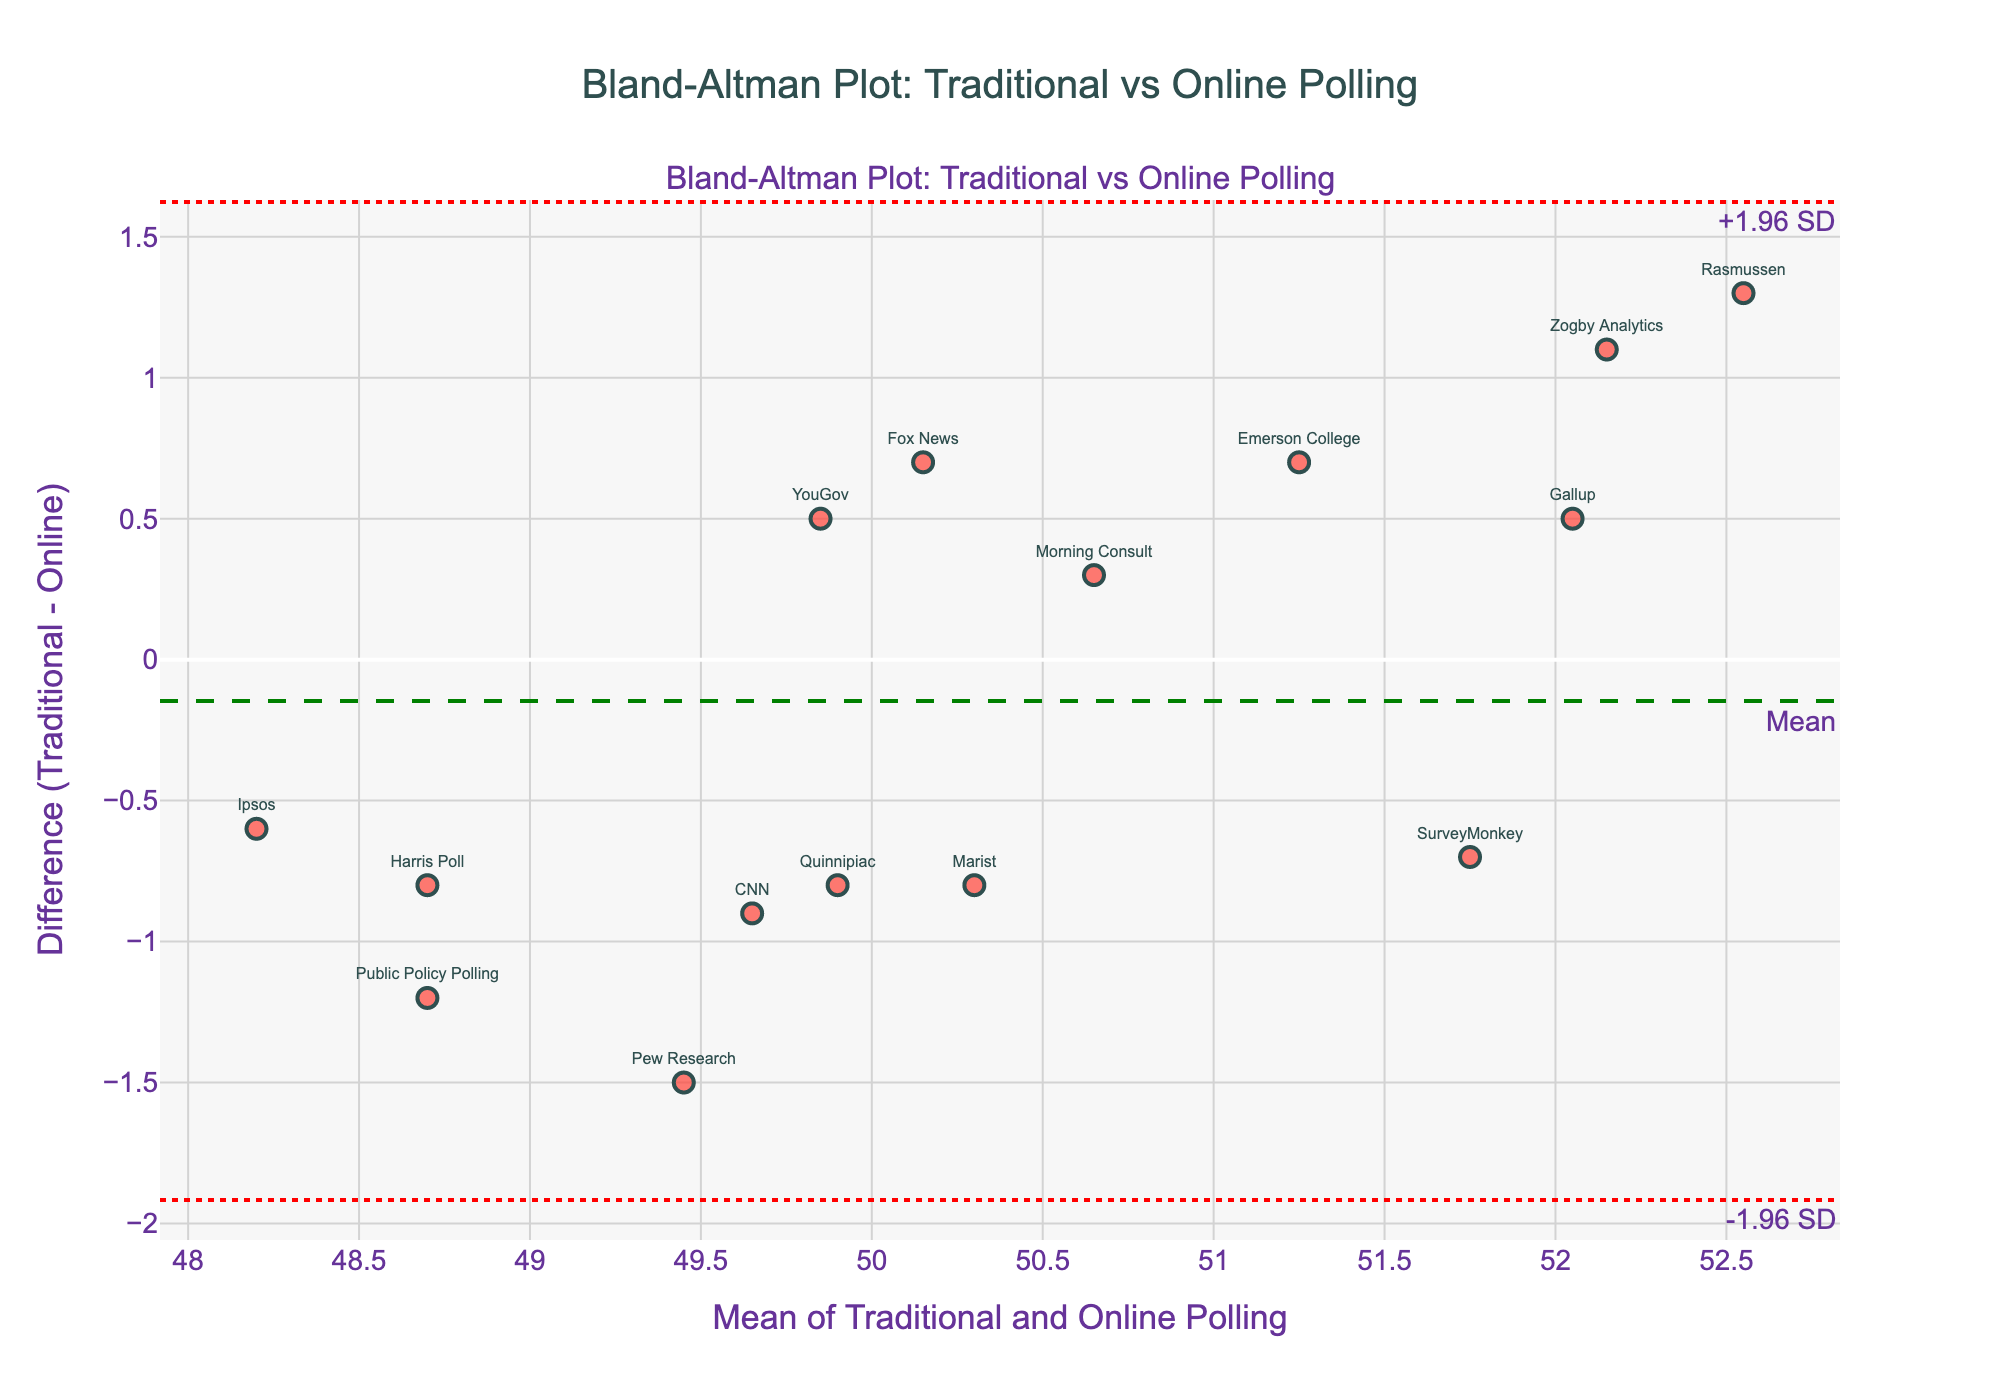What is the title of the plot? The title is displayed at the top of the figure.
Answer: Bland-Altman Plot: Traditional vs Online Polling How many data points are there in the plot? Count the number of markers in the scatter plot.
Answer: 15 What is the y-axis label in the plot? The y-axis label is displayed along the y-axis.
Answer: Difference (Traditional - Online) What is the mean difference shown in the plot? Identify the green dashed line representing the mean difference on the plot.
Answer: Approximately -0.2 Are there any points above the +1.96 SD line? Visually check if there are any markers above the red dashed line labeled "+1.96 SD".
Answer: Yes What is the range of means (x-axis) shown in the Bland-Altman plot? Observe the minimum and maximum values along the x-axis.
Answer: Approximately 48 to 52.5 Which polling method has the largest positive difference in results? Find the marker with the highest positive value on the y-axis and refer to its label.
Answer: Rasmussen (1.3) What polling methods are closest to the zero difference line? Look for markers closest to the y=0 line, and identify them.
Answer: Gallup, YouGov, Morning Consult, and Emerson College (0.3 to 0.5) Are the differences mostly positive or negative? Observe the distribution of the points relative to the zero difference line.
Answer: Mostly negative What are the limits of agreement (LoA) in the plot? Identify the y-values of the red dotted lines representing the limits of agreement.
Answer: Approximately -2.1 to 1.7 